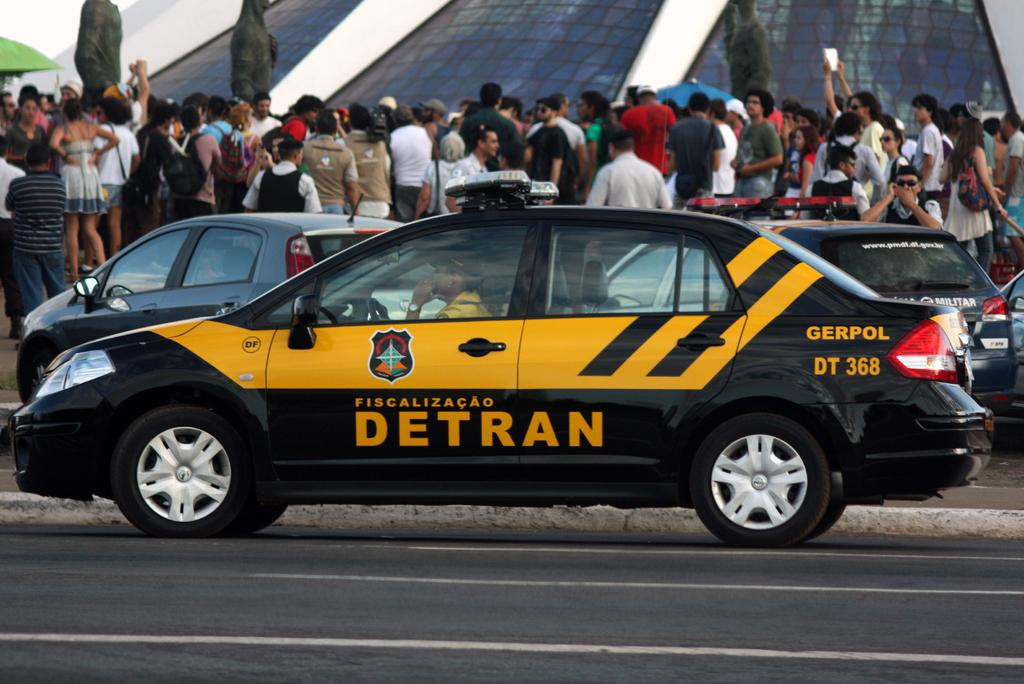<image>
Write a terse but informative summary of the picture. a car that has the word detran on it 